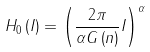<formula> <loc_0><loc_0><loc_500><loc_500>H _ { 0 } \left ( I \right ) = \left ( { \frac { 2 \pi } { \alpha G \left ( n \right ) } I } \right ) ^ { \alpha }</formula> 